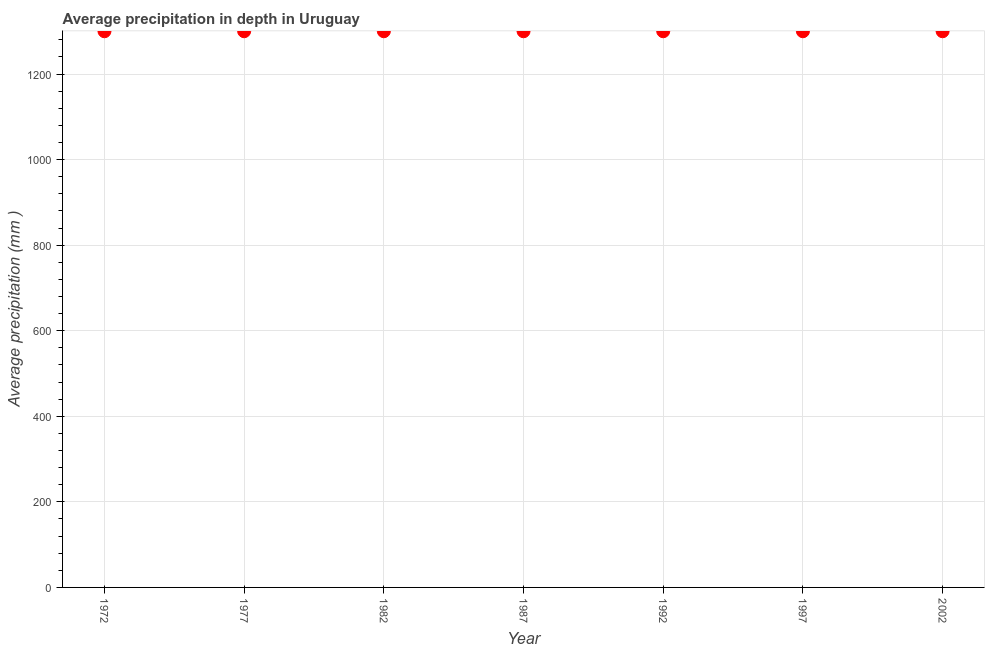What is the average precipitation in depth in 1977?
Give a very brief answer. 1300. Across all years, what is the maximum average precipitation in depth?
Offer a terse response. 1300. Across all years, what is the minimum average precipitation in depth?
Offer a very short reply. 1300. What is the sum of the average precipitation in depth?
Keep it short and to the point. 9100. What is the difference between the average precipitation in depth in 1987 and 1992?
Your answer should be very brief. 0. What is the average average precipitation in depth per year?
Offer a terse response. 1300. What is the median average precipitation in depth?
Keep it short and to the point. 1300. In how many years, is the average precipitation in depth greater than 400 mm?
Ensure brevity in your answer.  7. What is the ratio of the average precipitation in depth in 1992 to that in 2002?
Your answer should be compact. 1. Is the average precipitation in depth in 1982 less than that in 1992?
Give a very brief answer. No. Is the sum of the average precipitation in depth in 1972 and 1982 greater than the maximum average precipitation in depth across all years?
Provide a succinct answer. Yes. How many dotlines are there?
Offer a very short reply. 1. How many years are there in the graph?
Your answer should be compact. 7. Are the values on the major ticks of Y-axis written in scientific E-notation?
Offer a very short reply. No. Does the graph contain grids?
Ensure brevity in your answer.  Yes. What is the title of the graph?
Give a very brief answer. Average precipitation in depth in Uruguay. What is the label or title of the Y-axis?
Your answer should be compact. Average precipitation (mm ). What is the Average precipitation (mm ) in 1972?
Offer a terse response. 1300. What is the Average precipitation (mm ) in 1977?
Your answer should be very brief. 1300. What is the Average precipitation (mm ) in 1982?
Offer a very short reply. 1300. What is the Average precipitation (mm ) in 1987?
Your response must be concise. 1300. What is the Average precipitation (mm ) in 1992?
Your answer should be compact. 1300. What is the Average precipitation (mm ) in 1997?
Your response must be concise. 1300. What is the Average precipitation (mm ) in 2002?
Your answer should be compact. 1300. What is the difference between the Average precipitation (mm ) in 1972 and 1977?
Make the answer very short. 0. What is the difference between the Average precipitation (mm ) in 1972 and 1992?
Provide a short and direct response. 0. What is the difference between the Average precipitation (mm ) in 1977 and 1982?
Offer a very short reply. 0. What is the difference between the Average precipitation (mm ) in 1977 and 1992?
Make the answer very short. 0. What is the difference between the Average precipitation (mm ) in 1977 and 1997?
Your answer should be very brief. 0. What is the difference between the Average precipitation (mm ) in 1977 and 2002?
Keep it short and to the point. 0. What is the difference between the Average precipitation (mm ) in 1982 and 1987?
Provide a short and direct response. 0. What is the difference between the Average precipitation (mm ) in 1982 and 1992?
Your answer should be compact. 0. What is the difference between the Average precipitation (mm ) in 1982 and 1997?
Provide a short and direct response. 0. What is the difference between the Average precipitation (mm ) in 1982 and 2002?
Your response must be concise. 0. What is the difference between the Average precipitation (mm ) in 1987 and 1997?
Your answer should be very brief. 0. What is the difference between the Average precipitation (mm ) in 1992 and 1997?
Make the answer very short. 0. What is the difference between the Average precipitation (mm ) in 1992 and 2002?
Provide a succinct answer. 0. What is the ratio of the Average precipitation (mm ) in 1977 to that in 1987?
Your response must be concise. 1. What is the ratio of the Average precipitation (mm ) in 1977 to that in 1997?
Your response must be concise. 1. What is the ratio of the Average precipitation (mm ) in 1977 to that in 2002?
Your response must be concise. 1. What is the ratio of the Average precipitation (mm ) in 1982 to that in 1992?
Ensure brevity in your answer.  1. What is the ratio of the Average precipitation (mm ) in 1982 to that in 1997?
Offer a terse response. 1. What is the ratio of the Average precipitation (mm ) in 1987 to that in 1992?
Offer a very short reply. 1. What is the ratio of the Average precipitation (mm ) in 1987 to that in 1997?
Your answer should be very brief. 1. What is the ratio of the Average precipitation (mm ) in 1992 to that in 1997?
Ensure brevity in your answer.  1. What is the ratio of the Average precipitation (mm ) in 1997 to that in 2002?
Keep it short and to the point. 1. 